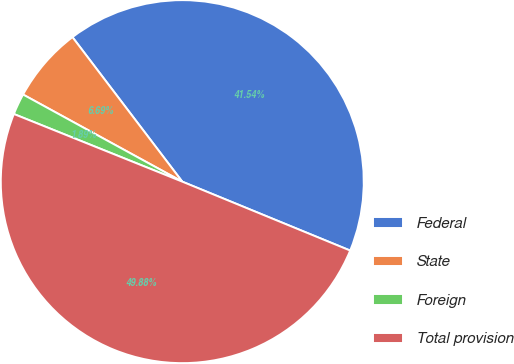Convert chart. <chart><loc_0><loc_0><loc_500><loc_500><pie_chart><fcel>Federal<fcel>State<fcel>Foreign<fcel>Total provision<nl><fcel>41.54%<fcel>6.69%<fcel>1.89%<fcel>49.88%<nl></chart> 